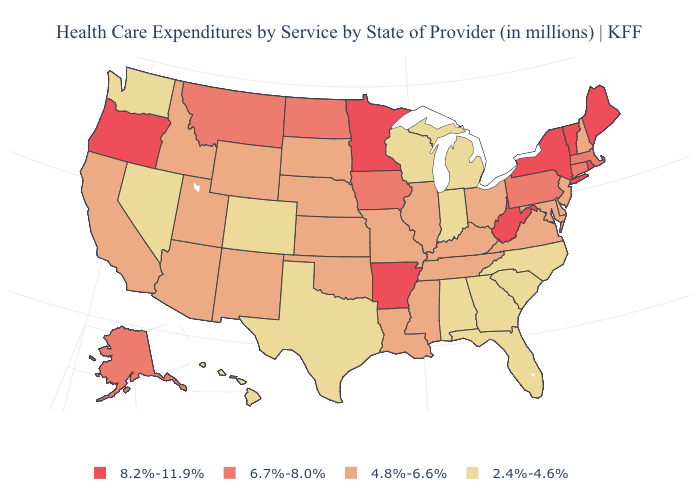Does Minnesota have the highest value in the MidWest?
Be succinct. Yes. Does Vermont have a higher value than Rhode Island?
Short answer required. No. Which states have the highest value in the USA?
Give a very brief answer. Arkansas, Maine, Minnesota, New York, Oregon, Rhode Island, Vermont, West Virginia. Name the states that have a value in the range 8.2%-11.9%?
Quick response, please. Arkansas, Maine, Minnesota, New York, Oregon, Rhode Island, Vermont, West Virginia. Does the first symbol in the legend represent the smallest category?
Give a very brief answer. No. What is the value of Iowa?
Keep it brief. 6.7%-8.0%. Name the states that have a value in the range 2.4%-4.6%?
Concise answer only. Alabama, Colorado, Florida, Georgia, Hawaii, Indiana, Michigan, Nevada, North Carolina, South Carolina, Texas, Washington, Wisconsin. Does North Carolina have the lowest value in the USA?
Keep it brief. Yes. Name the states that have a value in the range 6.7%-8.0%?
Short answer required. Alaska, Connecticut, Iowa, Massachusetts, Montana, North Dakota, Pennsylvania. What is the value of Georgia?
Be succinct. 2.4%-4.6%. Which states have the lowest value in the USA?
Quick response, please. Alabama, Colorado, Florida, Georgia, Hawaii, Indiana, Michigan, Nevada, North Carolina, South Carolina, Texas, Washington, Wisconsin. What is the value of New Jersey?
Short answer required. 4.8%-6.6%. What is the lowest value in the USA?
Concise answer only. 2.4%-4.6%. What is the lowest value in states that border Mississippi?
Quick response, please. 2.4%-4.6%. Which states hav the highest value in the South?
Concise answer only. Arkansas, West Virginia. 